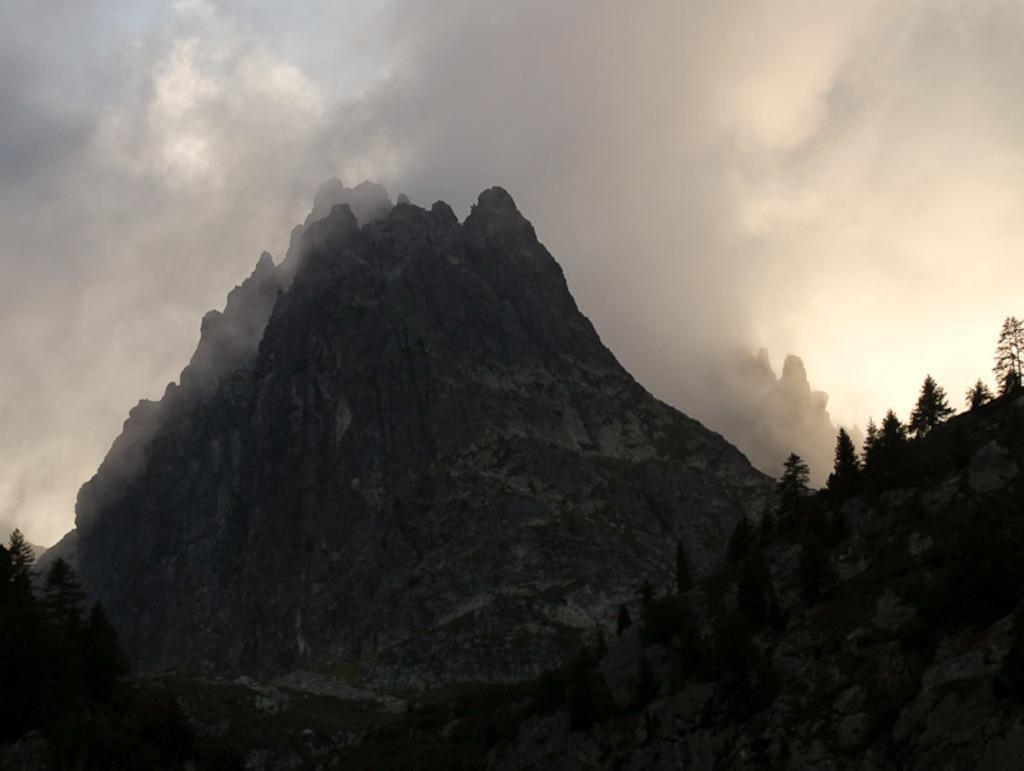Describe this image in one or two sentences. In this image, we can see hills, trees and smoke. Background there is the sky. 